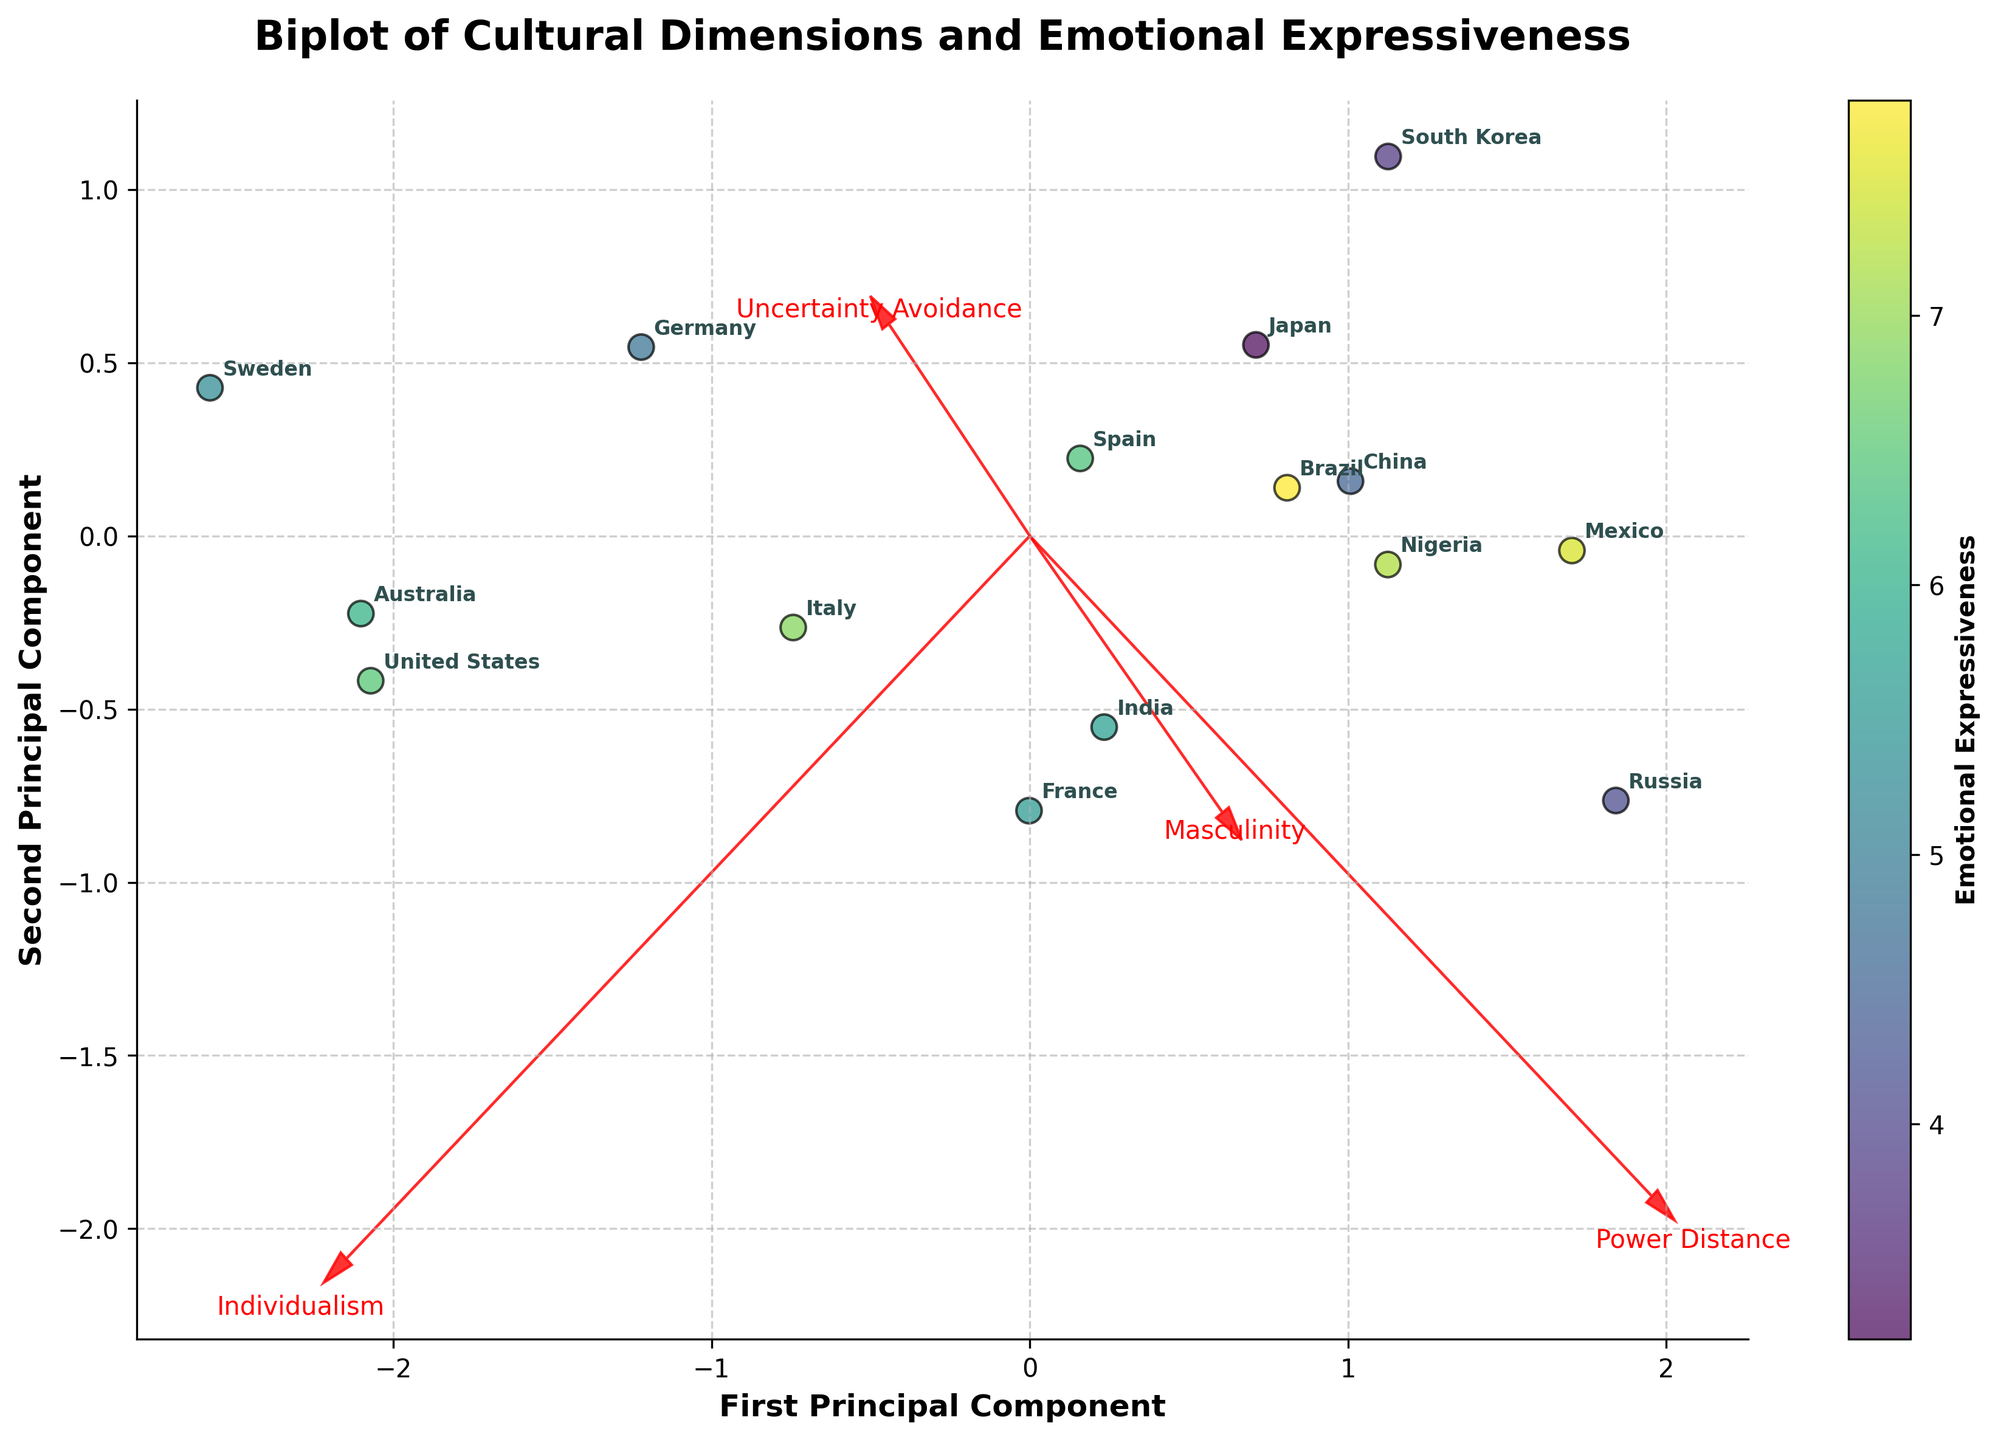What does the figure's title indicate? The title of the plot is "Biplot of Cultural Dimensions and Emotional Expressiveness," which indicates that the plot analyzes the relationship between various cultural dimensions and the emotional expressiveness of different countries.
Answer: The figure analyzes cultural dimensions and emotional expressiveness Which countries have the highest and lowest Emotional Expressiveness? By examining the color gradient representing Emotional Expressiveness, Brazil has the highest (darkest shade), and South Korea has the lowest (lightest shade).
Answer: Brazil has the highest, and South Korea has the lowest How many cultural dimensions are represented in the plot and what are they? The plot includes arrows labeled with four cultural dimensions: Power Distance, Individualism, Masculinity, and Uncertainty Avoidance.
Answer: Four dimensions: Power Distance, Individualism, Masculinity, Uncertainty Avoidance Which country is closest to the center of the plot? By looking at the scatter plot, Germany appears to be closest to the center of the plot.
Answer: Germany What can you infer about the relationship between Uncertainty Avoidance and Emotional Expressiveness? The arrow for Uncertainty Avoidance points towards the right and somewhat upwards, suggesting a partial positive correlation with the horizontal axis (First Principal Component). Countries with higher values in this component seem to generally have a higher Emotional Expressiveness.
Answer: Countries with higher Uncertainty Avoidance tend to have higher Emotional Expressiveness Which dimension most strongly contrasts with Individualism according to their vectors? By examining the direction of the arrows, Power Distance has its vector almost directly opposite to Individualism, indicating strong contrast.
Answer: Power Distance What is the general trend of Emotional Expressiveness across the countries with high Individualism? High Individualism countries such as the United States and Australia tend to have moderate Emotional Expressiveness, judging by the color gradient.
Answer: Moderate Emotional Expressiveness Which countries are positioned closely and have similar Emotional Expressiveness levels? Examining the clusters and color gradient, Italy and Spain are positioned closely and have similar Emotional Expressiveness levels (close to yellowish-green).
Answer: Italy and Spain Compare the Emotional Expressiveness of Nigeria and Sweden. Sweden is represented with a greenish color indicating moderate Emotional Expressiveness, while Nigeria has a darker green color indicating higher Emotional Expressiveness.
Answer: Nigeria has higher Emotional Expressiveness than Sweden What can be said about the countries with high Power Distance and low Individualism in terms of Emotional Expressiveness? Countries like China, Mexico, and Nigeria have high Power Distance and low Individualism. They display higher Emotional Expressiveness judging from the darker shades in the color gradient.
Answer: Higher Emotional Expressiveness 